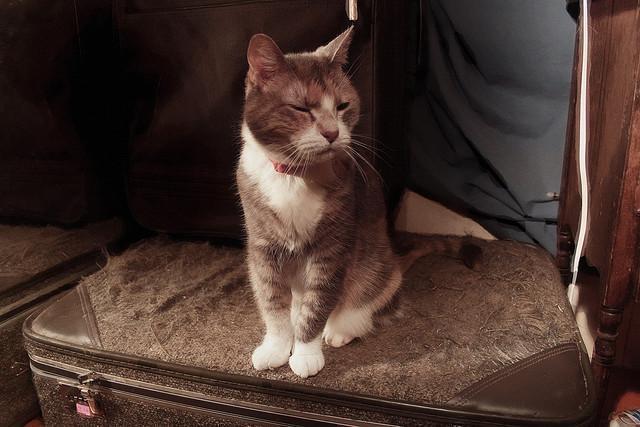How many suitcases are in the picture?
Give a very brief answer. 2. 